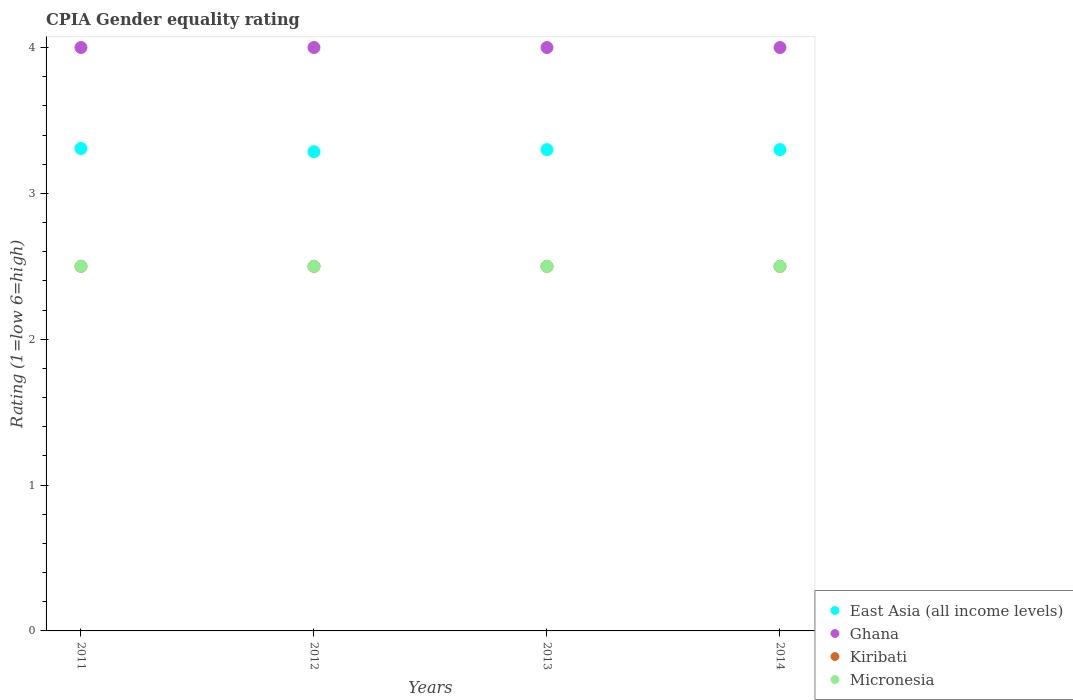How many different coloured dotlines are there?
Make the answer very short. 4. What is the CPIA rating in Ghana in 2014?
Your response must be concise. 4. Across all years, what is the maximum CPIA rating in East Asia (all income levels)?
Provide a succinct answer. 3.31. Across all years, what is the minimum CPIA rating in East Asia (all income levels)?
Ensure brevity in your answer.  3.29. What is the total CPIA rating in East Asia (all income levels) in the graph?
Your response must be concise. 13.19. What is the difference between the CPIA rating in East Asia (all income levels) in 2011 and the CPIA rating in Micronesia in 2014?
Your answer should be very brief. 0.81. What is the average CPIA rating in Micronesia per year?
Provide a short and direct response. 2.5. In the year 2011, what is the difference between the CPIA rating in Kiribati and CPIA rating in Ghana?
Keep it short and to the point. -1.5. Is the CPIA rating in Micronesia in 2011 less than that in 2014?
Give a very brief answer. No. Is the difference between the CPIA rating in Kiribati in 2011 and 2013 greater than the difference between the CPIA rating in Ghana in 2011 and 2013?
Ensure brevity in your answer.  No. What is the difference between the highest and the lowest CPIA rating in East Asia (all income levels)?
Give a very brief answer. 0.02. Is the sum of the CPIA rating in East Asia (all income levels) in 2011 and 2013 greater than the maximum CPIA rating in Kiribati across all years?
Provide a succinct answer. Yes. Is the CPIA rating in East Asia (all income levels) strictly less than the CPIA rating in Micronesia over the years?
Make the answer very short. No. Are the values on the major ticks of Y-axis written in scientific E-notation?
Provide a succinct answer. No. Does the graph contain any zero values?
Ensure brevity in your answer.  No. Does the graph contain grids?
Keep it short and to the point. No. Where does the legend appear in the graph?
Your answer should be very brief. Bottom right. How are the legend labels stacked?
Keep it short and to the point. Vertical. What is the title of the graph?
Offer a terse response. CPIA Gender equality rating. What is the label or title of the X-axis?
Keep it short and to the point. Years. What is the Rating (1=low 6=high) in East Asia (all income levels) in 2011?
Ensure brevity in your answer.  3.31. What is the Rating (1=low 6=high) of Kiribati in 2011?
Keep it short and to the point. 2.5. What is the Rating (1=low 6=high) of East Asia (all income levels) in 2012?
Ensure brevity in your answer.  3.29. What is the Rating (1=low 6=high) in Ghana in 2013?
Give a very brief answer. 4. What is the Rating (1=low 6=high) in Micronesia in 2013?
Provide a short and direct response. 2.5. What is the Rating (1=low 6=high) of Ghana in 2014?
Your answer should be compact. 4. What is the Rating (1=low 6=high) of Kiribati in 2014?
Your response must be concise. 2.5. What is the Rating (1=low 6=high) of Micronesia in 2014?
Keep it short and to the point. 2.5. Across all years, what is the maximum Rating (1=low 6=high) of East Asia (all income levels)?
Make the answer very short. 3.31. Across all years, what is the maximum Rating (1=low 6=high) of Ghana?
Ensure brevity in your answer.  4. Across all years, what is the maximum Rating (1=low 6=high) in Kiribati?
Your answer should be very brief. 2.5. Across all years, what is the maximum Rating (1=low 6=high) in Micronesia?
Your answer should be compact. 2.5. Across all years, what is the minimum Rating (1=low 6=high) of East Asia (all income levels)?
Provide a succinct answer. 3.29. Across all years, what is the minimum Rating (1=low 6=high) of Ghana?
Provide a short and direct response. 4. What is the total Rating (1=low 6=high) in East Asia (all income levels) in the graph?
Offer a very short reply. 13.19. What is the total Rating (1=low 6=high) of Micronesia in the graph?
Your answer should be compact. 10. What is the difference between the Rating (1=low 6=high) in East Asia (all income levels) in 2011 and that in 2012?
Offer a very short reply. 0.02. What is the difference between the Rating (1=low 6=high) of East Asia (all income levels) in 2011 and that in 2013?
Keep it short and to the point. 0.01. What is the difference between the Rating (1=low 6=high) of Kiribati in 2011 and that in 2013?
Give a very brief answer. 0. What is the difference between the Rating (1=low 6=high) in East Asia (all income levels) in 2011 and that in 2014?
Provide a short and direct response. 0.01. What is the difference between the Rating (1=low 6=high) of Ghana in 2011 and that in 2014?
Offer a terse response. 0. What is the difference between the Rating (1=low 6=high) of Kiribati in 2011 and that in 2014?
Keep it short and to the point. 0. What is the difference between the Rating (1=low 6=high) in East Asia (all income levels) in 2012 and that in 2013?
Ensure brevity in your answer.  -0.01. What is the difference between the Rating (1=low 6=high) in Ghana in 2012 and that in 2013?
Keep it short and to the point. 0. What is the difference between the Rating (1=low 6=high) of Kiribati in 2012 and that in 2013?
Make the answer very short. 0. What is the difference between the Rating (1=low 6=high) of East Asia (all income levels) in 2012 and that in 2014?
Provide a short and direct response. -0.01. What is the difference between the Rating (1=low 6=high) in Ghana in 2012 and that in 2014?
Give a very brief answer. 0. What is the difference between the Rating (1=low 6=high) in Kiribati in 2012 and that in 2014?
Offer a very short reply. 0. What is the difference between the Rating (1=low 6=high) in Ghana in 2013 and that in 2014?
Keep it short and to the point. 0. What is the difference between the Rating (1=low 6=high) in Kiribati in 2013 and that in 2014?
Keep it short and to the point. 0. What is the difference between the Rating (1=low 6=high) of Micronesia in 2013 and that in 2014?
Keep it short and to the point. 0. What is the difference between the Rating (1=low 6=high) in East Asia (all income levels) in 2011 and the Rating (1=low 6=high) in Ghana in 2012?
Give a very brief answer. -0.69. What is the difference between the Rating (1=low 6=high) in East Asia (all income levels) in 2011 and the Rating (1=low 6=high) in Kiribati in 2012?
Keep it short and to the point. 0.81. What is the difference between the Rating (1=low 6=high) in East Asia (all income levels) in 2011 and the Rating (1=low 6=high) in Micronesia in 2012?
Ensure brevity in your answer.  0.81. What is the difference between the Rating (1=low 6=high) of Ghana in 2011 and the Rating (1=low 6=high) of Micronesia in 2012?
Keep it short and to the point. 1.5. What is the difference between the Rating (1=low 6=high) in Kiribati in 2011 and the Rating (1=low 6=high) in Micronesia in 2012?
Provide a succinct answer. 0. What is the difference between the Rating (1=low 6=high) in East Asia (all income levels) in 2011 and the Rating (1=low 6=high) in Ghana in 2013?
Provide a succinct answer. -0.69. What is the difference between the Rating (1=low 6=high) of East Asia (all income levels) in 2011 and the Rating (1=low 6=high) of Kiribati in 2013?
Keep it short and to the point. 0.81. What is the difference between the Rating (1=low 6=high) of East Asia (all income levels) in 2011 and the Rating (1=low 6=high) of Micronesia in 2013?
Your response must be concise. 0.81. What is the difference between the Rating (1=low 6=high) in Ghana in 2011 and the Rating (1=low 6=high) in Kiribati in 2013?
Make the answer very short. 1.5. What is the difference between the Rating (1=low 6=high) of Ghana in 2011 and the Rating (1=low 6=high) of Micronesia in 2013?
Give a very brief answer. 1.5. What is the difference between the Rating (1=low 6=high) in East Asia (all income levels) in 2011 and the Rating (1=low 6=high) in Ghana in 2014?
Make the answer very short. -0.69. What is the difference between the Rating (1=low 6=high) in East Asia (all income levels) in 2011 and the Rating (1=low 6=high) in Kiribati in 2014?
Offer a very short reply. 0.81. What is the difference between the Rating (1=low 6=high) of East Asia (all income levels) in 2011 and the Rating (1=low 6=high) of Micronesia in 2014?
Make the answer very short. 0.81. What is the difference between the Rating (1=low 6=high) of Ghana in 2011 and the Rating (1=low 6=high) of Kiribati in 2014?
Provide a succinct answer. 1.5. What is the difference between the Rating (1=low 6=high) of East Asia (all income levels) in 2012 and the Rating (1=low 6=high) of Ghana in 2013?
Offer a terse response. -0.71. What is the difference between the Rating (1=low 6=high) of East Asia (all income levels) in 2012 and the Rating (1=low 6=high) of Kiribati in 2013?
Offer a very short reply. 0.79. What is the difference between the Rating (1=low 6=high) of East Asia (all income levels) in 2012 and the Rating (1=low 6=high) of Micronesia in 2013?
Provide a succinct answer. 0.79. What is the difference between the Rating (1=low 6=high) of Ghana in 2012 and the Rating (1=low 6=high) of Micronesia in 2013?
Make the answer very short. 1.5. What is the difference between the Rating (1=low 6=high) in East Asia (all income levels) in 2012 and the Rating (1=low 6=high) in Ghana in 2014?
Your response must be concise. -0.71. What is the difference between the Rating (1=low 6=high) of East Asia (all income levels) in 2012 and the Rating (1=low 6=high) of Kiribati in 2014?
Provide a short and direct response. 0.79. What is the difference between the Rating (1=low 6=high) of East Asia (all income levels) in 2012 and the Rating (1=low 6=high) of Micronesia in 2014?
Provide a short and direct response. 0.79. What is the difference between the Rating (1=low 6=high) of Ghana in 2012 and the Rating (1=low 6=high) of Kiribati in 2014?
Offer a very short reply. 1.5. What is the difference between the Rating (1=low 6=high) of East Asia (all income levels) in 2013 and the Rating (1=low 6=high) of Ghana in 2014?
Give a very brief answer. -0.7. What is the difference between the Rating (1=low 6=high) in East Asia (all income levels) in 2013 and the Rating (1=low 6=high) in Micronesia in 2014?
Ensure brevity in your answer.  0.8. What is the difference between the Rating (1=low 6=high) in Kiribati in 2013 and the Rating (1=low 6=high) in Micronesia in 2014?
Offer a very short reply. 0. What is the average Rating (1=low 6=high) in East Asia (all income levels) per year?
Make the answer very short. 3.3. What is the average Rating (1=low 6=high) in Micronesia per year?
Provide a short and direct response. 2.5. In the year 2011, what is the difference between the Rating (1=low 6=high) of East Asia (all income levels) and Rating (1=low 6=high) of Ghana?
Your answer should be very brief. -0.69. In the year 2011, what is the difference between the Rating (1=low 6=high) in East Asia (all income levels) and Rating (1=low 6=high) in Kiribati?
Offer a very short reply. 0.81. In the year 2011, what is the difference between the Rating (1=low 6=high) in East Asia (all income levels) and Rating (1=low 6=high) in Micronesia?
Your answer should be very brief. 0.81. In the year 2011, what is the difference between the Rating (1=low 6=high) in Ghana and Rating (1=low 6=high) in Kiribati?
Your answer should be compact. 1.5. In the year 2012, what is the difference between the Rating (1=low 6=high) of East Asia (all income levels) and Rating (1=low 6=high) of Ghana?
Offer a terse response. -0.71. In the year 2012, what is the difference between the Rating (1=low 6=high) of East Asia (all income levels) and Rating (1=low 6=high) of Kiribati?
Make the answer very short. 0.79. In the year 2012, what is the difference between the Rating (1=low 6=high) in East Asia (all income levels) and Rating (1=low 6=high) in Micronesia?
Ensure brevity in your answer.  0.79. In the year 2012, what is the difference between the Rating (1=low 6=high) of Kiribati and Rating (1=low 6=high) of Micronesia?
Make the answer very short. 0. In the year 2013, what is the difference between the Rating (1=low 6=high) of East Asia (all income levels) and Rating (1=low 6=high) of Kiribati?
Ensure brevity in your answer.  0.8. In the year 2013, what is the difference between the Rating (1=low 6=high) of East Asia (all income levels) and Rating (1=low 6=high) of Micronesia?
Give a very brief answer. 0.8. In the year 2013, what is the difference between the Rating (1=low 6=high) of Ghana and Rating (1=low 6=high) of Micronesia?
Provide a short and direct response. 1.5. In the year 2013, what is the difference between the Rating (1=low 6=high) in Kiribati and Rating (1=low 6=high) in Micronesia?
Provide a short and direct response. 0. What is the ratio of the Rating (1=low 6=high) of Ghana in 2011 to that in 2012?
Your answer should be very brief. 1. What is the ratio of the Rating (1=low 6=high) of Kiribati in 2011 to that in 2012?
Your response must be concise. 1. What is the ratio of the Rating (1=low 6=high) of Micronesia in 2011 to that in 2012?
Offer a very short reply. 1. What is the ratio of the Rating (1=low 6=high) of East Asia (all income levels) in 2011 to that in 2013?
Provide a short and direct response. 1. What is the ratio of the Rating (1=low 6=high) in Kiribati in 2011 to that in 2014?
Provide a succinct answer. 1. What is the ratio of the Rating (1=low 6=high) in East Asia (all income levels) in 2012 to that in 2013?
Keep it short and to the point. 1. What is the ratio of the Rating (1=low 6=high) in Ghana in 2012 to that in 2013?
Offer a very short reply. 1. What is the ratio of the Rating (1=low 6=high) of Kiribati in 2012 to that in 2013?
Your answer should be compact. 1. What is the ratio of the Rating (1=low 6=high) in Micronesia in 2012 to that in 2013?
Your response must be concise. 1. What is the ratio of the Rating (1=low 6=high) of East Asia (all income levels) in 2012 to that in 2014?
Offer a terse response. 1. What is the ratio of the Rating (1=low 6=high) in Ghana in 2013 to that in 2014?
Provide a short and direct response. 1. What is the difference between the highest and the second highest Rating (1=low 6=high) in East Asia (all income levels)?
Your answer should be very brief. 0.01. What is the difference between the highest and the second highest Rating (1=low 6=high) of Kiribati?
Provide a short and direct response. 0. What is the difference between the highest and the second highest Rating (1=low 6=high) of Micronesia?
Your answer should be very brief. 0. What is the difference between the highest and the lowest Rating (1=low 6=high) in East Asia (all income levels)?
Your response must be concise. 0.02. What is the difference between the highest and the lowest Rating (1=low 6=high) in Micronesia?
Ensure brevity in your answer.  0. 